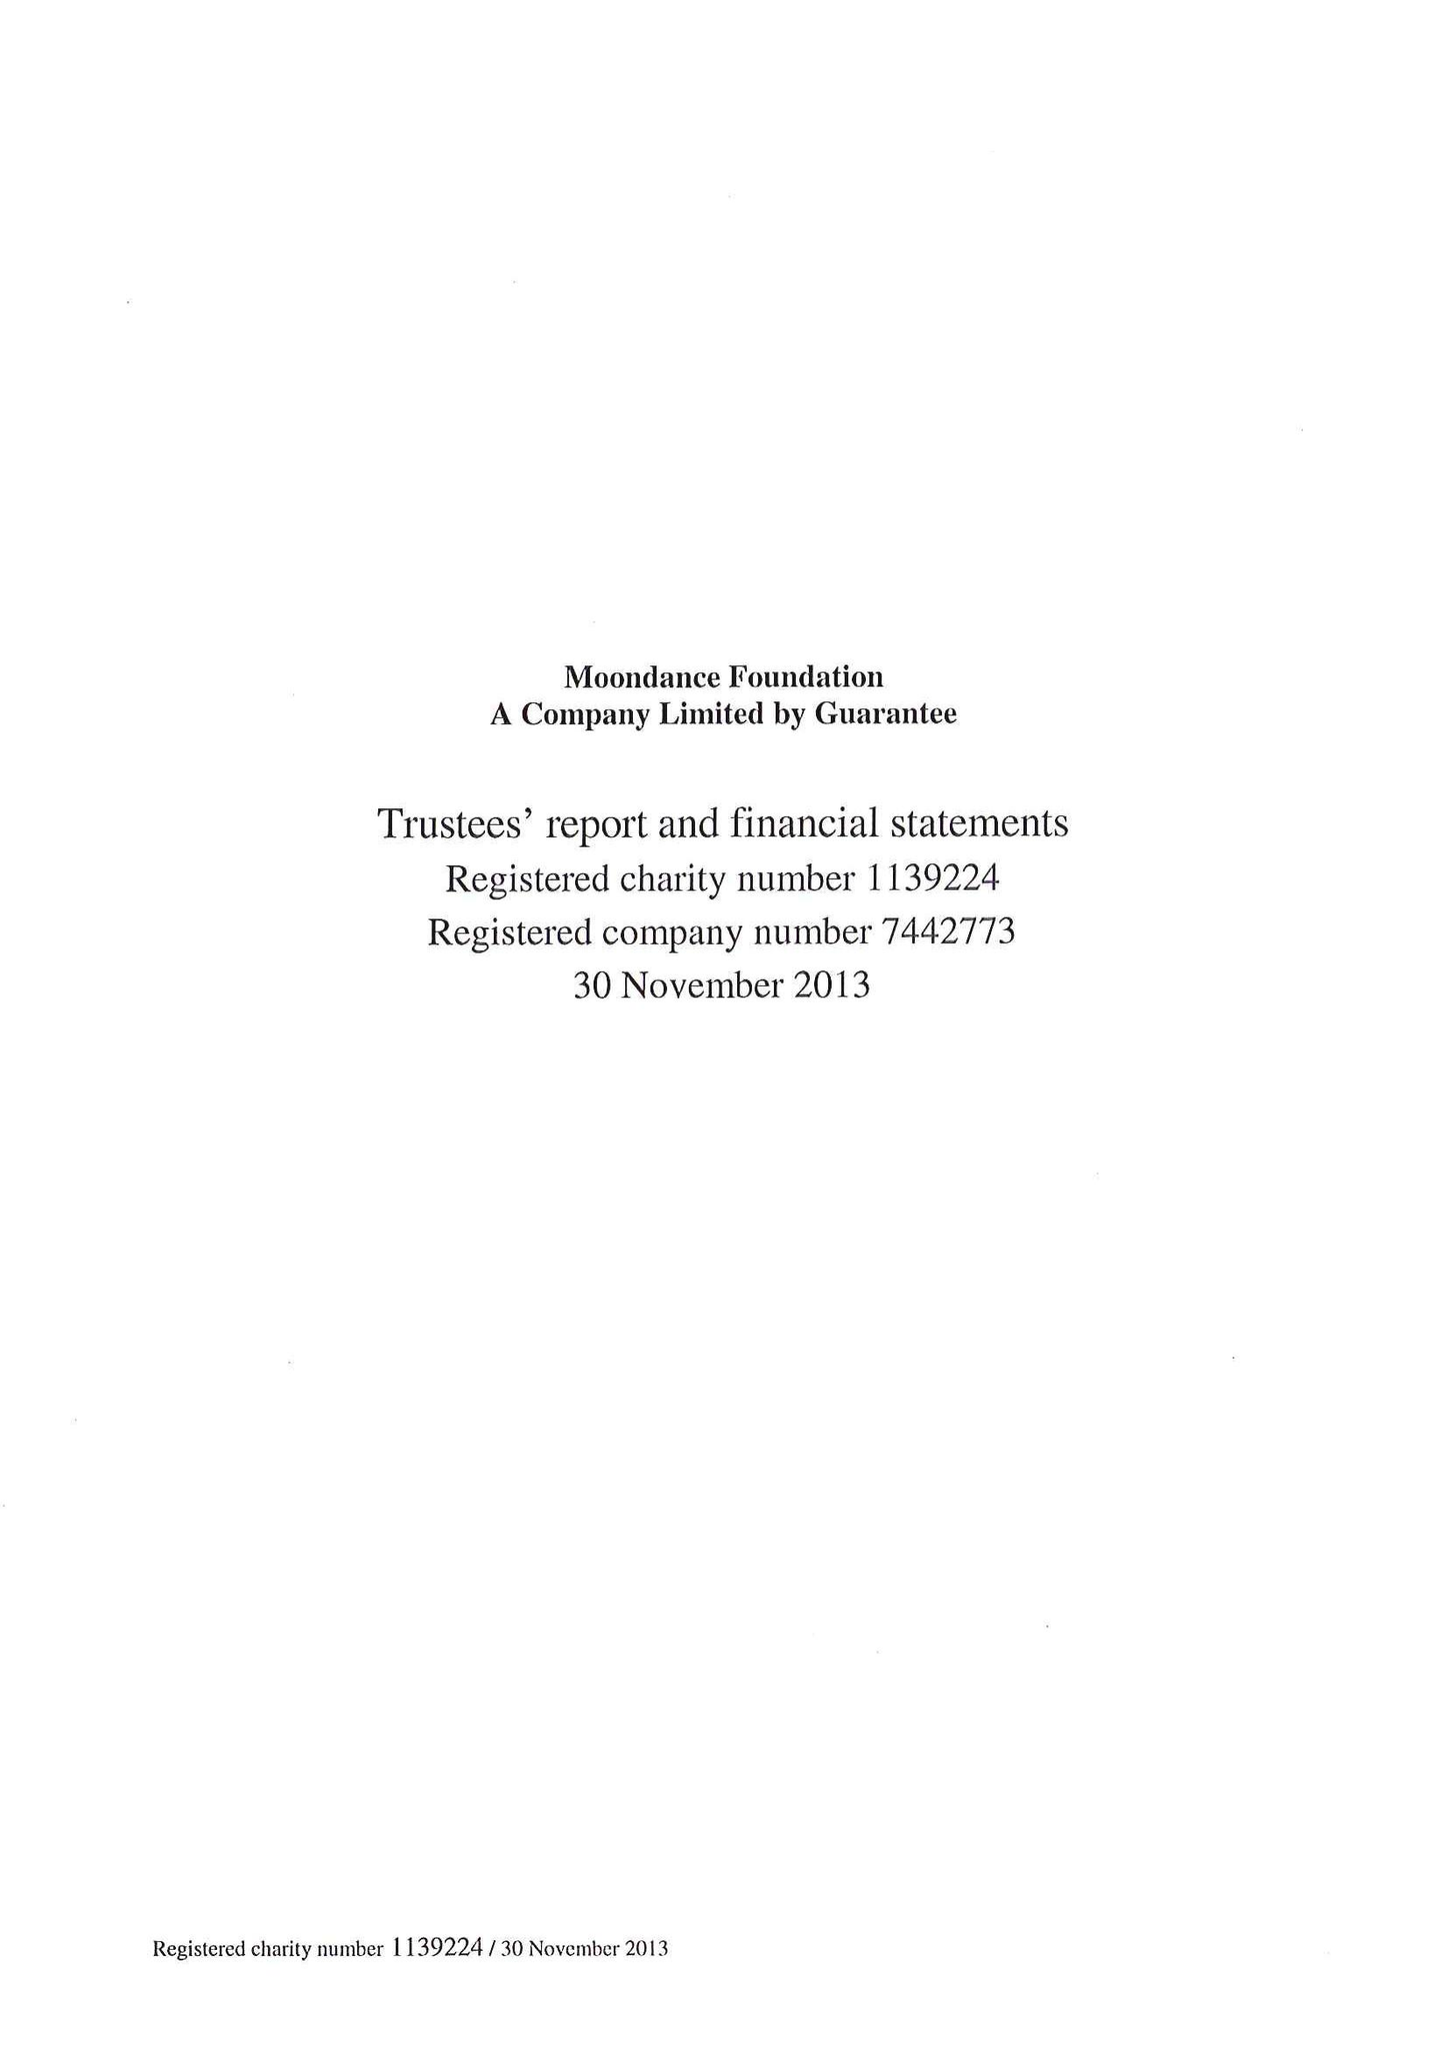What is the value for the address__postcode?
Answer the question using a single word or phrase. NP20 1LA 